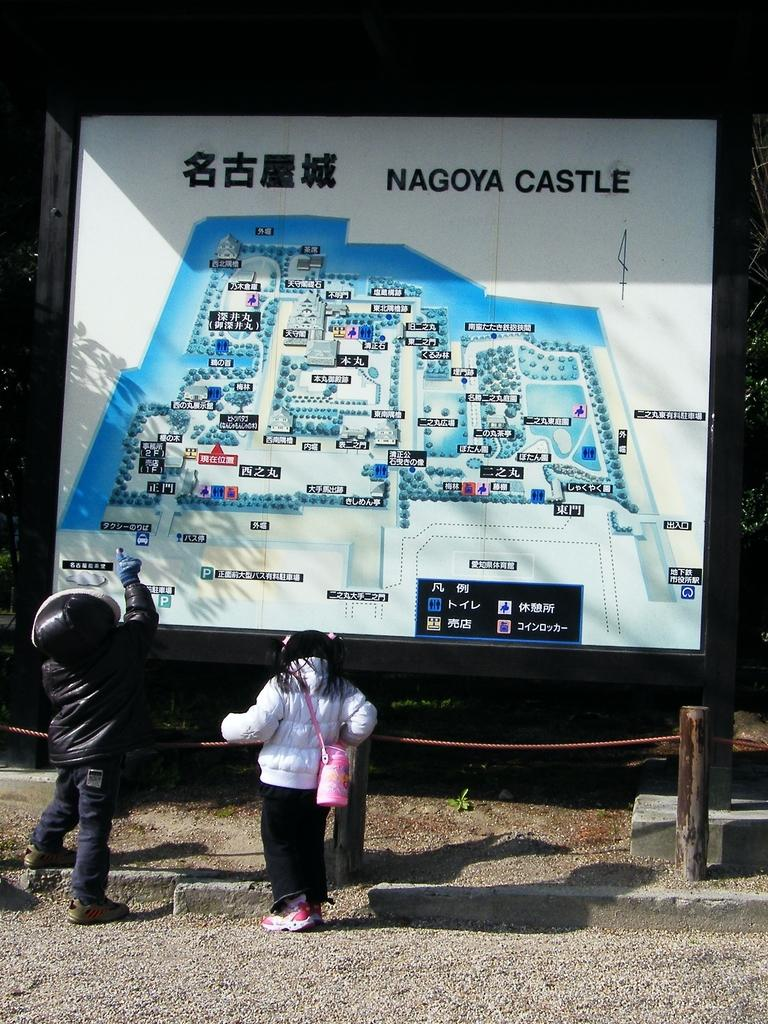How many people are in the image? There are two people in the image, a man and a woman. What are the man and woman doing in the image? The man and woman are standing near a large board. Can you describe any other objects or features in the image? There is a rope tied to a pole in the image. What type of wren can be seen perched on the woman's shoulder in the image? There is no wren present in the image; it only features a man and a woman standing near a large board and a rope tied to a pole. 